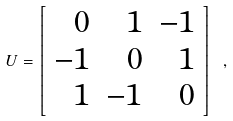<formula> <loc_0><loc_0><loc_500><loc_500>U = \left [ \begin{array} { r r r } 0 & 1 & - 1 \\ - 1 & 0 & 1 \\ 1 & - 1 & 0 \end{array} \right ] \ ,</formula> 